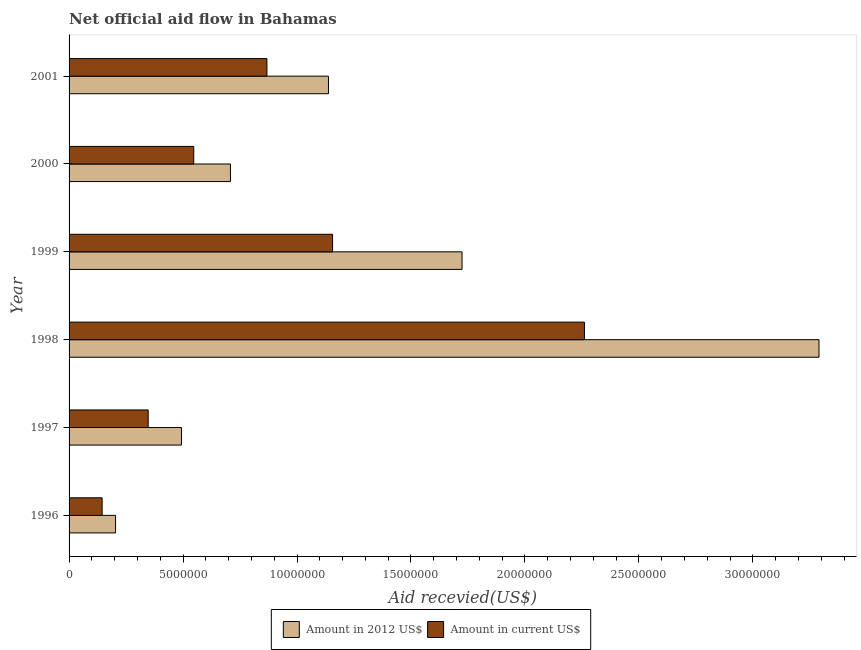Are the number of bars per tick equal to the number of legend labels?
Provide a short and direct response. Yes. Are the number of bars on each tick of the Y-axis equal?
Offer a very short reply. Yes. How many bars are there on the 6th tick from the top?
Your response must be concise. 2. How many bars are there on the 6th tick from the bottom?
Offer a very short reply. 2. What is the label of the 1st group of bars from the top?
Keep it short and to the point. 2001. What is the amount of aid received(expressed in us$) in 1996?
Give a very brief answer. 1.45e+06. Across all years, what is the maximum amount of aid received(expressed in 2012 us$)?
Give a very brief answer. 3.29e+07. Across all years, what is the minimum amount of aid received(expressed in 2012 us$)?
Ensure brevity in your answer.  2.04e+06. In which year was the amount of aid received(expressed in us$) maximum?
Ensure brevity in your answer.  1998. In which year was the amount of aid received(expressed in 2012 us$) minimum?
Provide a short and direct response. 1996. What is the total amount of aid received(expressed in 2012 us$) in the graph?
Make the answer very short. 7.56e+07. What is the difference between the amount of aid received(expressed in 2012 us$) in 1999 and that in 2001?
Provide a short and direct response. 5.86e+06. What is the difference between the amount of aid received(expressed in 2012 us$) in 1996 and the amount of aid received(expressed in us$) in 1999?
Your answer should be compact. -9.52e+06. What is the average amount of aid received(expressed in us$) per year?
Your answer should be very brief. 8.87e+06. In the year 1997, what is the difference between the amount of aid received(expressed in 2012 us$) and amount of aid received(expressed in us$)?
Provide a short and direct response. 1.46e+06. In how many years, is the amount of aid received(expressed in us$) greater than 9000000 US$?
Make the answer very short. 2. What is the ratio of the amount of aid received(expressed in us$) in 1996 to that in 2001?
Offer a very short reply. 0.17. Is the amount of aid received(expressed in 2012 us$) in 1998 less than that in 1999?
Ensure brevity in your answer.  No. What is the difference between the highest and the second highest amount of aid received(expressed in 2012 us$)?
Offer a terse response. 1.57e+07. What is the difference between the highest and the lowest amount of aid received(expressed in us$)?
Give a very brief answer. 2.12e+07. In how many years, is the amount of aid received(expressed in 2012 us$) greater than the average amount of aid received(expressed in 2012 us$) taken over all years?
Keep it short and to the point. 2. What does the 1st bar from the top in 2000 represents?
Provide a short and direct response. Amount in current US$. What does the 2nd bar from the bottom in 1996 represents?
Your response must be concise. Amount in current US$. How many bars are there?
Keep it short and to the point. 12. What is the difference between two consecutive major ticks on the X-axis?
Make the answer very short. 5.00e+06. Where does the legend appear in the graph?
Offer a terse response. Bottom center. How are the legend labels stacked?
Offer a very short reply. Horizontal. What is the title of the graph?
Offer a very short reply. Net official aid flow in Bahamas. Does "Taxes" appear as one of the legend labels in the graph?
Offer a terse response. No. What is the label or title of the X-axis?
Provide a short and direct response. Aid recevied(US$). What is the label or title of the Y-axis?
Your answer should be very brief. Year. What is the Aid recevied(US$) in Amount in 2012 US$ in 1996?
Your response must be concise. 2.04e+06. What is the Aid recevied(US$) of Amount in current US$ in 1996?
Offer a terse response. 1.45e+06. What is the Aid recevied(US$) in Amount in 2012 US$ in 1997?
Offer a terse response. 4.93e+06. What is the Aid recevied(US$) of Amount in current US$ in 1997?
Provide a short and direct response. 3.47e+06. What is the Aid recevied(US$) in Amount in 2012 US$ in 1998?
Offer a very short reply. 3.29e+07. What is the Aid recevied(US$) of Amount in current US$ in 1998?
Your response must be concise. 2.26e+07. What is the Aid recevied(US$) in Amount in 2012 US$ in 1999?
Your response must be concise. 1.72e+07. What is the Aid recevied(US$) of Amount in current US$ in 1999?
Keep it short and to the point. 1.16e+07. What is the Aid recevied(US$) in Amount in 2012 US$ in 2000?
Your response must be concise. 7.08e+06. What is the Aid recevied(US$) of Amount in current US$ in 2000?
Keep it short and to the point. 5.47e+06. What is the Aid recevied(US$) of Amount in 2012 US$ in 2001?
Offer a very short reply. 1.14e+07. What is the Aid recevied(US$) of Amount in current US$ in 2001?
Offer a very short reply. 8.68e+06. Across all years, what is the maximum Aid recevied(US$) of Amount in 2012 US$?
Offer a terse response. 3.29e+07. Across all years, what is the maximum Aid recevied(US$) of Amount in current US$?
Make the answer very short. 2.26e+07. Across all years, what is the minimum Aid recevied(US$) in Amount in 2012 US$?
Make the answer very short. 2.04e+06. Across all years, what is the minimum Aid recevied(US$) in Amount in current US$?
Offer a terse response. 1.45e+06. What is the total Aid recevied(US$) of Amount in 2012 US$ in the graph?
Keep it short and to the point. 7.56e+07. What is the total Aid recevied(US$) of Amount in current US$ in the graph?
Offer a very short reply. 5.32e+07. What is the difference between the Aid recevied(US$) of Amount in 2012 US$ in 1996 and that in 1997?
Your answer should be very brief. -2.89e+06. What is the difference between the Aid recevied(US$) of Amount in current US$ in 1996 and that in 1997?
Your answer should be very brief. -2.02e+06. What is the difference between the Aid recevied(US$) of Amount in 2012 US$ in 1996 and that in 1998?
Ensure brevity in your answer.  -3.09e+07. What is the difference between the Aid recevied(US$) of Amount in current US$ in 1996 and that in 1998?
Provide a short and direct response. -2.12e+07. What is the difference between the Aid recevied(US$) in Amount in 2012 US$ in 1996 and that in 1999?
Ensure brevity in your answer.  -1.52e+07. What is the difference between the Aid recevied(US$) in Amount in current US$ in 1996 and that in 1999?
Provide a succinct answer. -1.01e+07. What is the difference between the Aid recevied(US$) in Amount in 2012 US$ in 1996 and that in 2000?
Your response must be concise. -5.04e+06. What is the difference between the Aid recevied(US$) in Amount in current US$ in 1996 and that in 2000?
Your answer should be compact. -4.02e+06. What is the difference between the Aid recevied(US$) in Amount in 2012 US$ in 1996 and that in 2001?
Offer a very short reply. -9.34e+06. What is the difference between the Aid recevied(US$) in Amount in current US$ in 1996 and that in 2001?
Your answer should be compact. -7.23e+06. What is the difference between the Aid recevied(US$) of Amount in 2012 US$ in 1997 and that in 1998?
Make the answer very short. -2.80e+07. What is the difference between the Aid recevied(US$) of Amount in current US$ in 1997 and that in 1998?
Offer a very short reply. -1.91e+07. What is the difference between the Aid recevied(US$) of Amount in 2012 US$ in 1997 and that in 1999?
Make the answer very short. -1.23e+07. What is the difference between the Aid recevied(US$) of Amount in current US$ in 1997 and that in 1999?
Provide a succinct answer. -8.09e+06. What is the difference between the Aid recevied(US$) in Amount in 2012 US$ in 1997 and that in 2000?
Provide a succinct answer. -2.15e+06. What is the difference between the Aid recevied(US$) in Amount in current US$ in 1997 and that in 2000?
Make the answer very short. -2.00e+06. What is the difference between the Aid recevied(US$) of Amount in 2012 US$ in 1997 and that in 2001?
Offer a very short reply. -6.45e+06. What is the difference between the Aid recevied(US$) of Amount in current US$ in 1997 and that in 2001?
Offer a terse response. -5.21e+06. What is the difference between the Aid recevied(US$) of Amount in 2012 US$ in 1998 and that in 1999?
Offer a terse response. 1.57e+07. What is the difference between the Aid recevied(US$) of Amount in current US$ in 1998 and that in 1999?
Offer a terse response. 1.10e+07. What is the difference between the Aid recevied(US$) of Amount in 2012 US$ in 1998 and that in 2000?
Keep it short and to the point. 2.58e+07. What is the difference between the Aid recevied(US$) in Amount in current US$ in 1998 and that in 2000?
Your answer should be compact. 1.71e+07. What is the difference between the Aid recevied(US$) of Amount in 2012 US$ in 1998 and that in 2001?
Ensure brevity in your answer.  2.15e+07. What is the difference between the Aid recevied(US$) of Amount in current US$ in 1998 and that in 2001?
Your answer should be compact. 1.39e+07. What is the difference between the Aid recevied(US$) of Amount in 2012 US$ in 1999 and that in 2000?
Your answer should be very brief. 1.02e+07. What is the difference between the Aid recevied(US$) of Amount in current US$ in 1999 and that in 2000?
Offer a terse response. 6.09e+06. What is the difference between the Aid recevied(US$) of Amount in 2012 US$ in 1999 and that in 2001?
Give a very brief answer. 5.86e+06. What is the difference between the Aid recevied(US$) in Amount in current US$ in 1999 and that in 2001?
Your answer should be very brief. 2.88e+06. What is the difference between the Aid recevied(US$) of Amount in 2012 US$ in 2000 and that in 2001?
Offer a very short reply. -4.30e+06. What is the difference between the Aid recevied(US$) in Amount in current US$ in 2000 and that in 2001?
Ensure brevity in your answer.  -3.21e+06. What is the difference between the Aid recevied(US$) of Amount in 2012 US$ in 1996 and the Aid recevied(US$) of Amount in current US$ in 1997?
Make the answer very short. -1.43e+06. What is the difference between the Aid recevied(US$) of Amount in 2012 US$ in 1996 and the Aid recevied(US$) of Amount in current US$ in 1998?
Give a very brief answer. -2.06e+07. What is the difference between the Aid recevied(US$) in Amount in 2012 US$ in 1996 and the Aid recevied(US$) in Amount in current US$ in 1999?
Make the answer very short. -9.52e+06. What is the difference between the Aid recevied(US$) of Amount in 2012 US$ in 1996 and the Aid recevied(US$) of Amount in current US$ in 2000?
Offer a terse response. -3.43e+06. What is the difference between the Aid recevied(US$) of Amount in 2012 US$ in 1996 and the Aid recevied(US$) of Amount in current US$ in 2001?
Your answer should be compact. -6.64e+06. What is the difference between the Aid recevied(US$) of Amount in 2012 US$ in 1997 and the Aid recevied(US$) of Amount in current US$ in 1998?
Give a very brief answer. -1.77e+07. What is the difference between the Aid recevied(US$) in Amount in 2012 US$ in 1997 and the Aid recevied(US$) in Amount in current US$ in 1999?
Ensure brevity in your answer.  -6.63e+06. What is the difference between the Aid recevied(US$) of Amount in 2012 US$ in 1997 and the Aid recevied(US$) of Amount in current US$ in 2000?
Provide a succinct answer. -5.40e+05. What is the difference between the Aid recevied(US$) in Amount in 2012 US$ in 1997 and the Aid recevied(US$) in Amount in current US$ in 2001?
Provide a succinct answer. -3.75e+06. What is the difference between the Aid recevied(US$) of Amount in 2012 US$ in 1998 and the Aid recevied(US$) of Amount in current US$ in 1999?
Provide a short and direct response. 2.13e+07. What is the difference between the Aid recevied(US$) in Amount in 2012 US$ in 1998 and the Aid recevied(US$) in Amount in current US$ in 2000?
Keep it short and to the point. 2.74e+07. What is the difference between the Aid recevied(US$) of Amount in 2012 US$ in 1998 and the Aid recevied(US$) of Amount in current US$ in 2001?
Ensure brevity in your answer.  2.42e+07. What is the difference between the Aid recevied(US$) of Amount in 2012 US$ in 1999 and the Aid recevied(US$) of Amount in current US$ in 2000?
Provide a short and direct response. 1.18e+07. What is the difference between the Aid recevied(US$) of Amount in 2012 US$ in 1999 and the Aid recevied(US$) of Amount in current US$ in 2001?
Provide a succinct answer. 8.56e+06. What is the difference between the Aid recevied(US$) of Amount in 2012 US$ in 2000 and the Aid recevied(US$) of Amount in current US$ in 2001?
Your answer should be very brief. -1.60e+06. What is the average Aid recevied(US$) of Amount in 2012 US$ per year?
Offer a very short reply. 1.26e+07. What is the average Aid recevied(US$) in Amount in current US$ per year?
Offer a terse response. 8.87e+06. In the year 1996, what is the difference between the Aid recevied(US$) in Amount in 2012 US$ and Aid recevied(US$) in Amount in current US$?
Give a very brief answer. 5.90e+05. In the year 1997, what is the difference between the Aid recevied(US$) in Amount in 2012 US$ and Aid recevied(US$) in Amount in current US$?
Provide a short and direct response. 1.46e+06. In the year 1998, what is the difference between the Aid recevied(US$) of Amount in 2012 US$ and Aid recevied(US$) of Amount in current US$?
Give a very brief answer. 1.03e+07. In the year 1999, what is the difference between the Aid recevied(US$) of Amount in 2012 US$ and Aid recevied(US$) of Amount in current US$?
Make the answer very short. 5.68e+06. In the year 2000, what is the difference between the Aid recevied(US$) in Amount in 2012 US$ and Aid recevied(US$) in Amount in current US$?
Ensure brevity in your answer.  1.61e+06. In the year 2001, what is the difference between the Aid recevied(US$) of Amount in 2012 US$ and Aid recevied(US$) of Amount in current US$?
Your response must be concise. 2.70e+06. What is the ratio of the Aid recevied(US$) in Amount in 2012 US$ in 1996 to that in 1997?
Offer a terse response. 0.41. What is the ratio of the Aid recevied(US$) in Amount in current US$ in 1996 to that in 1997?
Provide a short and direct response. 0.42. What is the ratio of the Aid recevied(US$) of Amount in 2012 US$ in 1996 to that in 1998?
Ensure brevity in your answer.  0.06. What is the ratio of the Aid recevied(US$) of Amount in current US$ in 1996 to that in 1998?
Your answer should be very brief. 0.06. What is the ratio of the Aid recevied(US$) in Amount in 2012 US$ in 1996 to that in 1999?
Keep it short and to the point. 0.12. What is the ratio of the Aid recevied(US$) in Amount in current US$ in 1996 to that in 1999?
Your answer should be very brief. 0.13. What is the ratio of the Aid recevied(US$) of Amount in 2012 US$ in 1996 to that in 2000?
Offer a terse response. 0.29. What is the ratio of the Aid recevied(US$) in Amount in current US$ in 1996 to that in 2000?
Make the answer very short. 0.27. What is the ratio of the Aid recevied(US$) in Amount in 2012 US$ in 1996 to that in 2001?
Give a very brief answer. 0.18. What is the ratio of the Aid recevied(US$) of Amount in current US$ in 1996 to that in 2001?
Your answer should be very brief. 0.17. What is the ratio of the Aid recevied(US$) in Amount in 2012 US$ in 1997 to that in 1998?
Provide a short and direct response. 0.15. What is the ratio of the Aid recevied(US$) of Amount in current US$ in 1997 to that in 1998?
Give a very brief answer. 0.15. What is the ratio of the Aid recevied(US$) in Amount in 2012 US$ in 1997 to that in 1999?
Your response must be concise. 0.29. What is the ratio of the Aid recevied(US$) in Amount in current US$ in 1997 to that in 1999?
Provide a succinct answer. 0.3. What is the ratio of the Aid recevied(US$) in Amount in 2012 US$ in 1997 to that in 2000?
Provide a succinct answer. 0.7. What is the ratio of the Aid recevied(US$) of Amount in current US$ in 1997 to that in 2000?
Make the answer very short. 0.63. What is the ratio of the Aid recevied(US$) of Amount in 2012 US$ in 1997 to that in 2001?
Your response must be concise. 0.43. What is the ratio of the Aid recevied(US$) in Amount in current US$ in 1997 to that in 2001?
Ensure brevity in your answer.  0.4. What is the ratio of the Aid recevied(US$) of Amount in 2012 US$ in 1998 to that in 1999?
Your answer should be very brief. 1.91. What is the ratio of the Aid recevied(US$) of Amount in current US$ in 1998 to that in 1999?
Ensure brevity in your answer.  1.96. What is the ratio of the Aid recevied(US$) in Amount in 2012 US$ in 1998 to that in 2000?
Make the answer very short. 4.65. What is the ratio of the Aid recevied(US$) in Amount in current US$ in 1998 to that in 2000?
Offer a very short reply. 4.13. What is the ratio of the Aid recevied(US$) in Amount in 2012 US$ in 1998 to that in 2001?
Offer a very short reply. 2.89. What is the ratio of the Aid recevied(US$) of Amount in current US$ in 1998 to that in 2001?
Offer a terse response. 2.6. What is the ratio of the Aid recevied(US$) in Amount in 2012 US$ in 1999 to that in 2000?
Keep it short and to the point. 2.44. What is the ratio of the Aid recevied(US$) of Amount in current US$ in 1999 to that in 2000?
Keep it short and to the point. 2.11. What is the ratio of the Aid recevied(US$) in Amount in 2012 US$ in 1999 to that in 2001?
Your answer should be compact. 1.51. What is the ratio of the Aid recevied(US$) in Amount in current US$ in 1999 to that in 2001?
Ensure brevity in your answer.  1.33. What is the ratio of the Aid recevied(US$) of Amount in 2012 US$ in 2000 to that in 2001?
Give a very brief answer. 0.62. What is the ratio of the Aid recevied(US$) in Amount in current US$ in 2000 to that in 2001?
Your response must be concise. 0.63. What is the difference between the highest and the second highest Aid recevied(US$) in Amount in 2012 US$?
Offer a very short reply. 1.57e+07. What is the difference between the highest and the second highest Aid recevied(US$) of Amount in current US$?
Provide a succinct answer. 1.10e+07. What is the difference between the highest and the lowest Aid recevied(US$) in Amount in 2012 US$?
Your answer should be very brief. 3.09e+07. What is the difference between the highest and the lowest Aid recevied(US$) in Amount in current US$?
Offer a very short reply. 2.12e+07. 